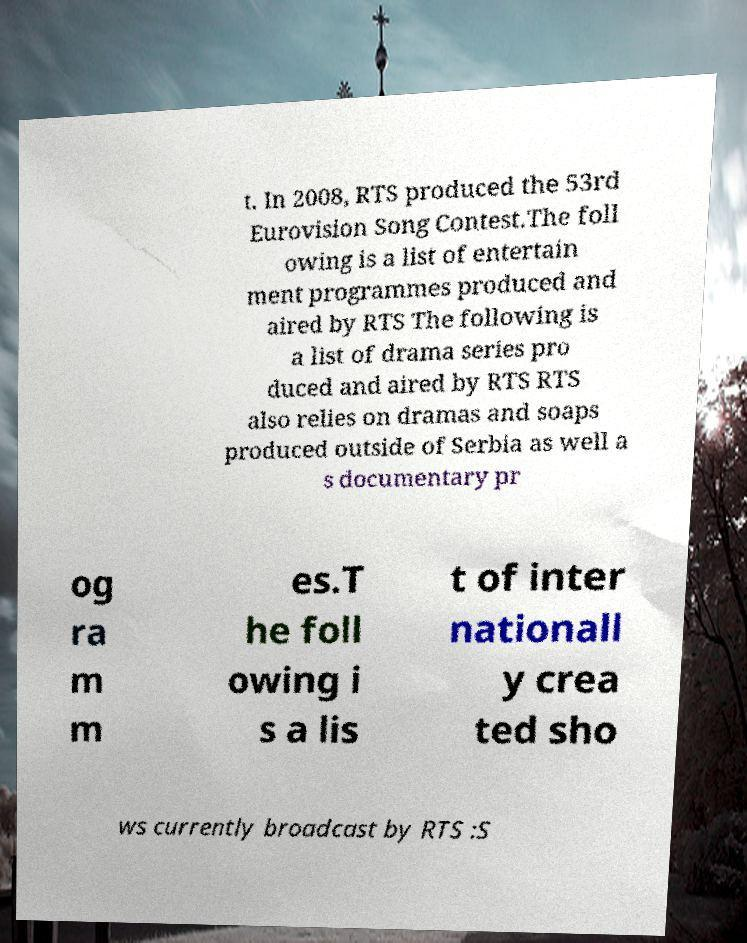Can you accurately transcribe the text from the provided image for me? t. In 2008, RTS produced the 53rd Eurovision Song Contest.The foll owing is a list of entertain ment programmes produced and aired by RTS The following is a list of drama series pro duced and aired by RTS RTS also relies on dramas and soaps produced outside of Serbia as well a s documentary pr og ra m m es.T he foll owing i s a lis t of inter nationall y crea ted sho ws currently broadcast by RTS :S 